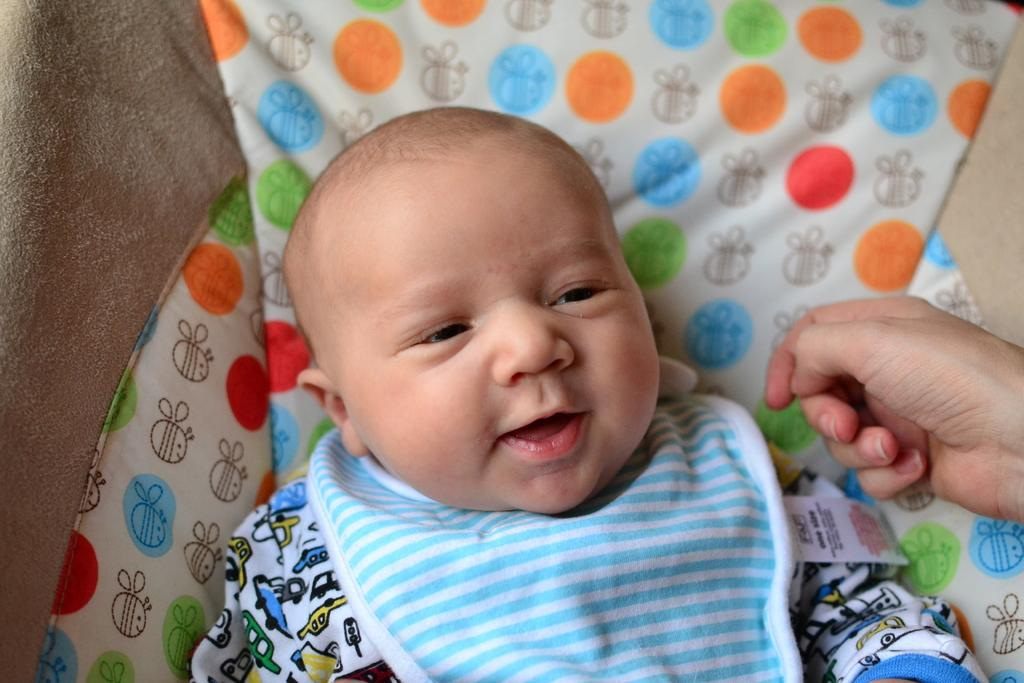What is the main subject of the image? There is a baby in a cradle in the image. Can you describe the baby's location in the image? The baby is in a cradle. What else can be seen in the image? There is a hand of a person on the right side of the image. How many ants are crawling on the baby in the image? There are no ants present in the image; it only features a baby in a cradle and a hand of a person on the right side. 